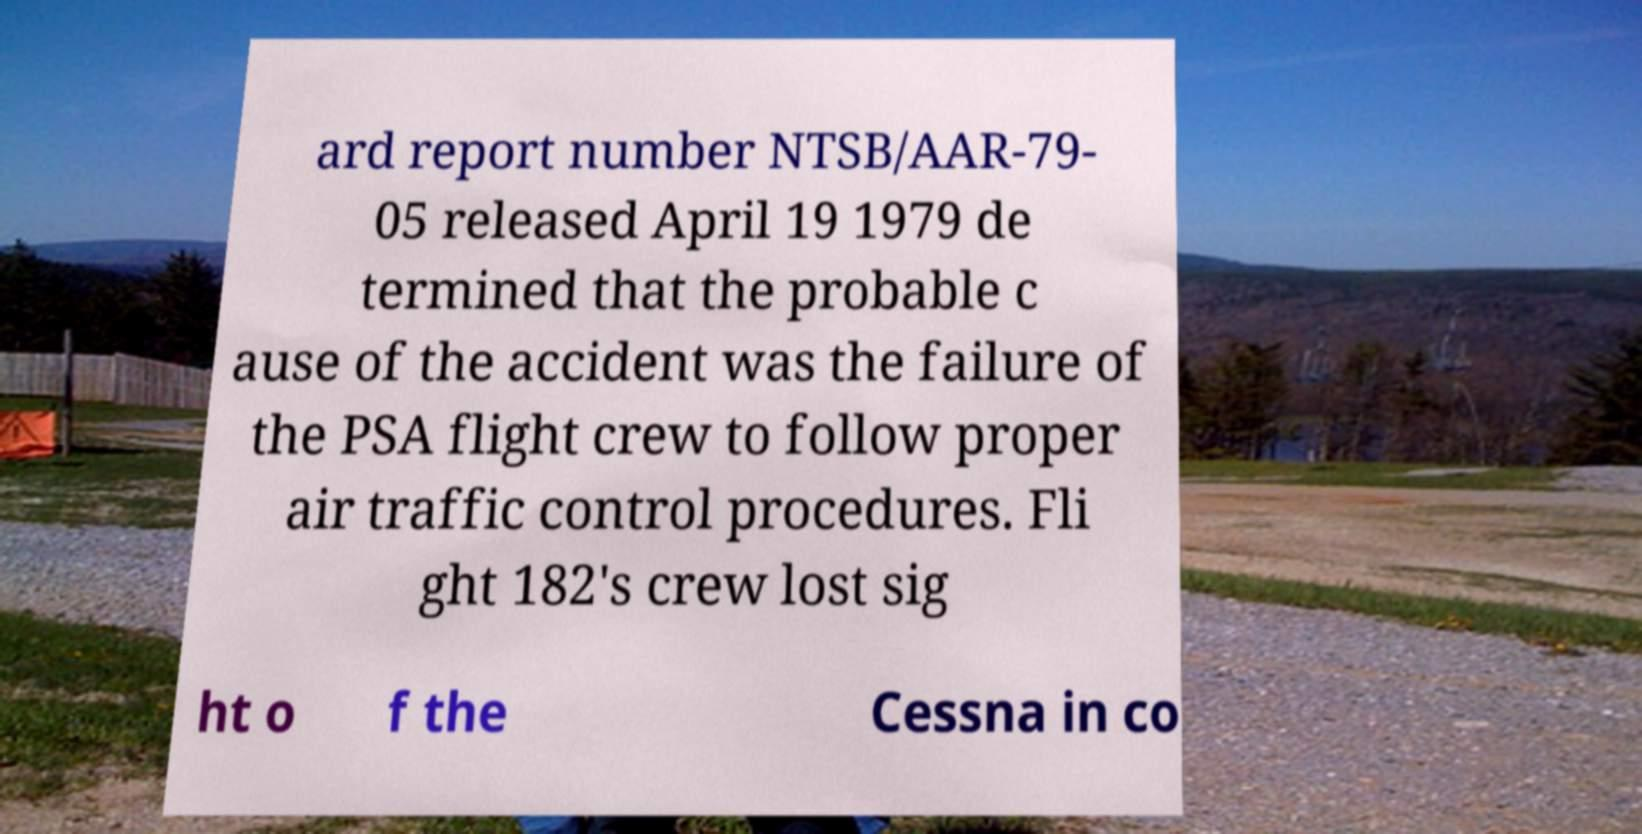Please identify and transcribe the text found in this image. ard report number NTSB/AAR-79- 05 released April 19 1979 de termined that the probable c ause of the accident was the failure of the PSA flight crew to follow proper air traffic control procedures. Fli ght 182's crew lost sig ht o f the Cessna in co 